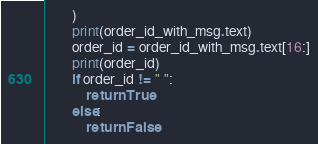Convert code to text. <code><loc_0><loc_0><loc_500><loc_500><_Python_>        )
        print(order_id_with_msg.text)
        order_id = order_id_with_msg.text[16:]
        print(order_id)
        if order_id != " ":
            return True
        else:
            return False</code> 